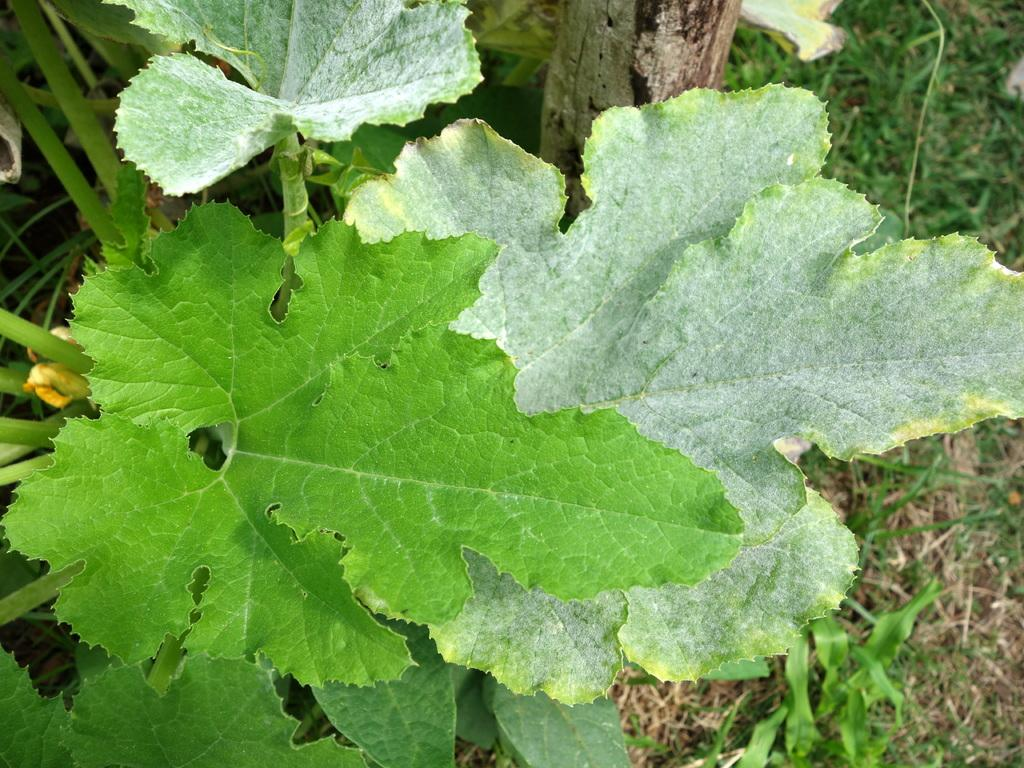What type of plant is in the image? There is a plant with green leaves in the image. What part of a tree can be seen at the top of the image? There is a tree trunk at the top of the image. What type of vegetation is visible in the background of the image? There is grass visible in the background of the image. What type of force is being exerted on the basketball in the image? There is no basketball present in the image, so it is not possible to determine what type of force might be exertedted on it. 